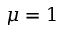<formula> <loc_0><loc_0><loc_500><loc_500>\mu = 1</formula> 